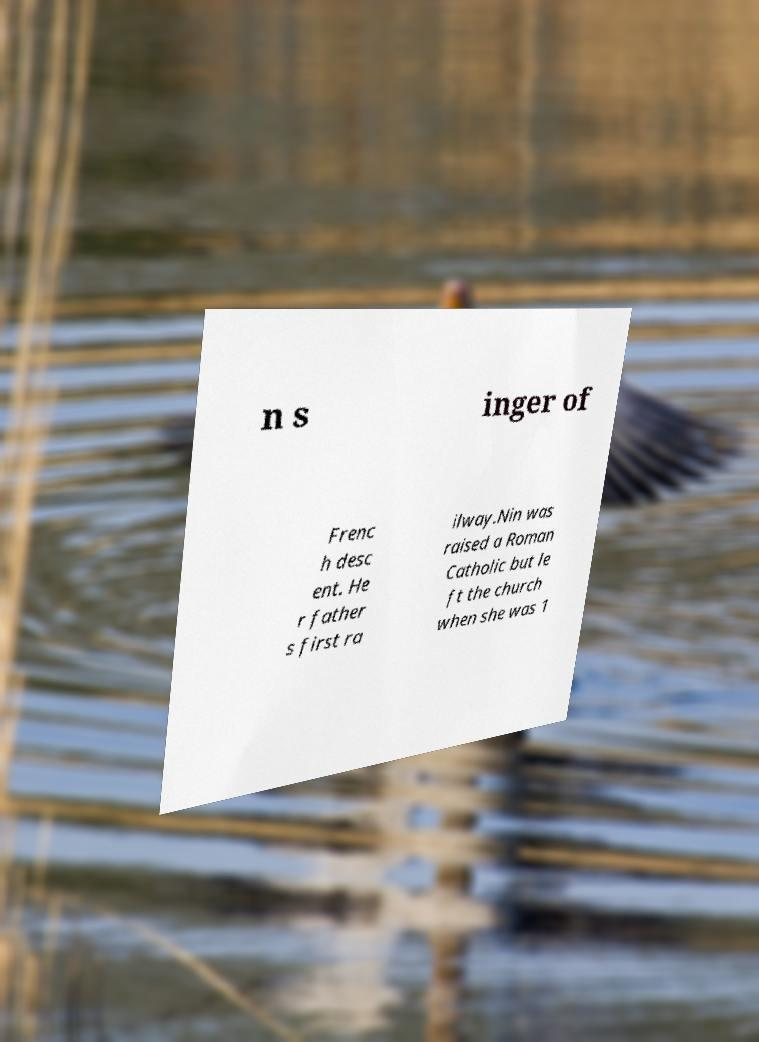Could you assist in decoding the text presented in this image and type it out clearly? n s inger of Frenc h desc ent. He r father s first ra ilway.Nin was raised a Roman Catholic but le ft the church when she was 1 